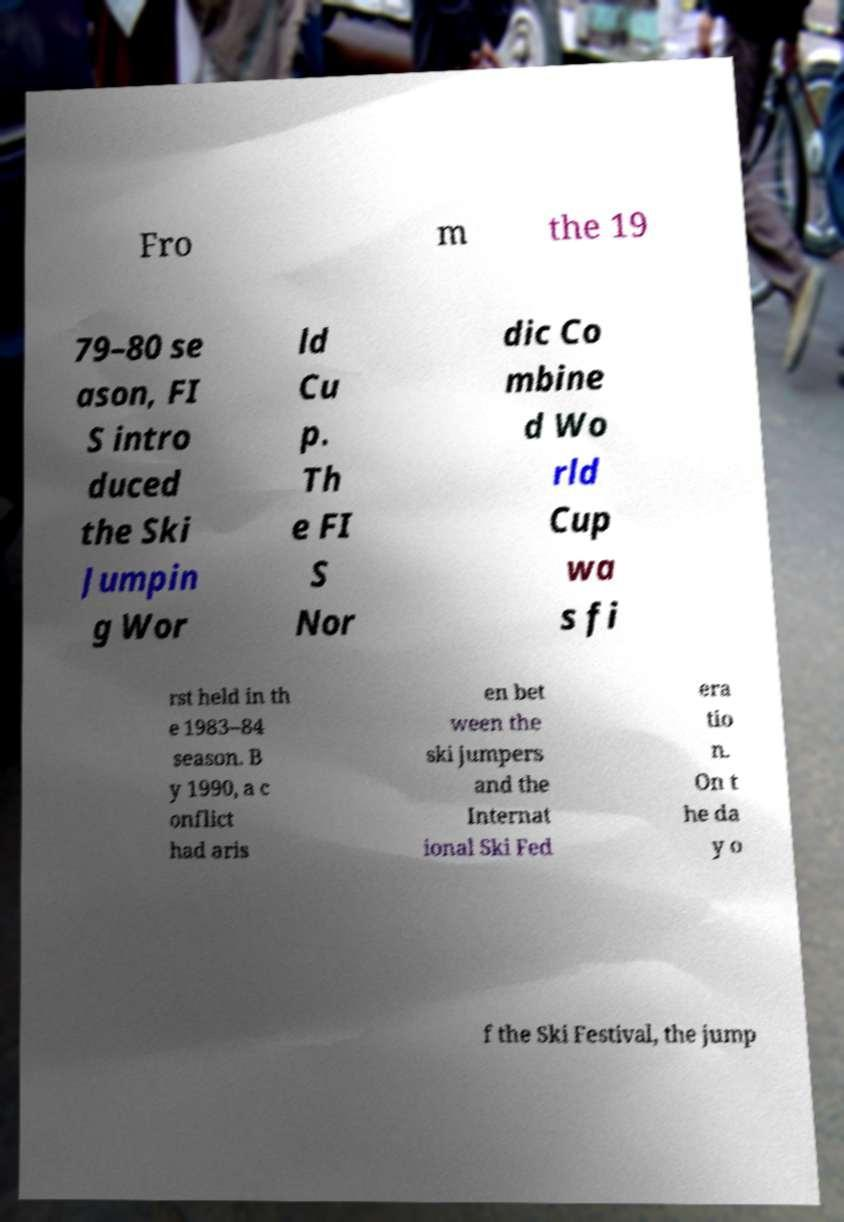Please read and relay the text visible in this image. What does it say? Fro m the 19 79–80 se ason, FI S intro duced the Ski Jumpin g Wor ld Cu p. Th e FI S Nor dic Co mbine d Wo rld Cup wa s fi rst held in th e 1983–84 season. B y 1990, a c onflict had aris en bet ween the ski jumpers and the Internat ional Ski Fed era tio n. On t he da y o f the Ski Festival, the jump 